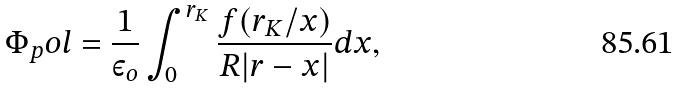<formula> <loc_0><loc_0><loc_500><loc_500>\Phi _ { p } o l = \frac { 1 } { \varepsilon _ { o } } \int _ { 0 } ^ { r _ { K } } \frac { f ( r _ { K } / x ) } { R | r - x | } d x ,</formula> 